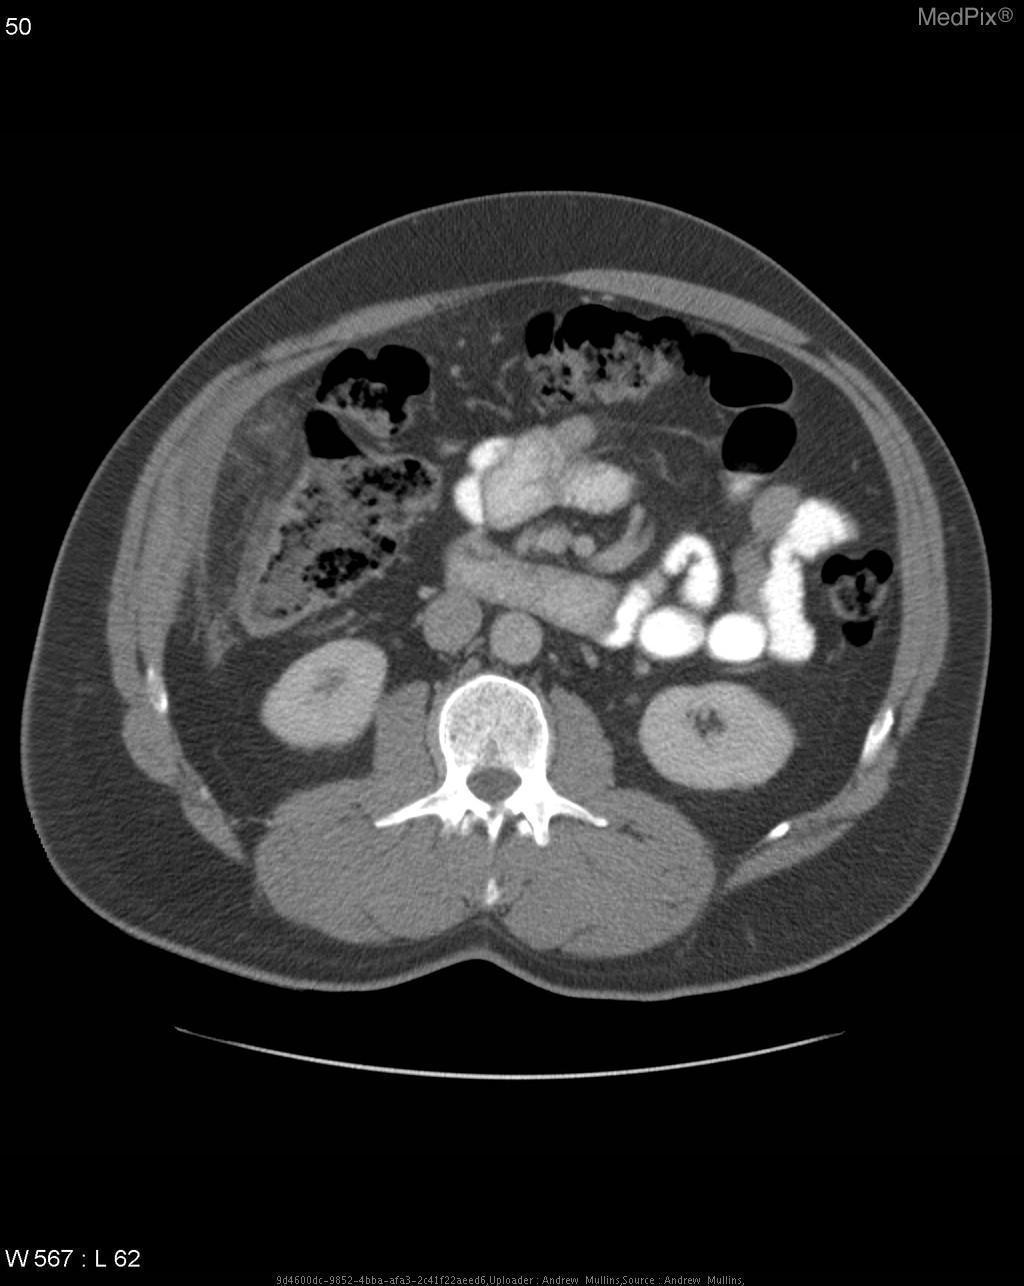Is there a fracture in the vertebrae seen?
Keep it brief. No. Are there any abnormalities in the kidneys?
Quick response, please. No. Notice any abnormality in the kidneys?
Quick response, please. No. 